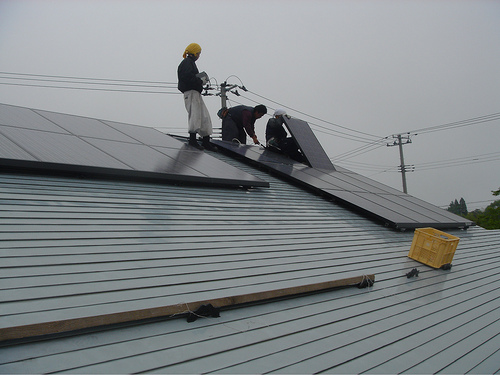<image>
Is the man on the hat? No. The man is not positioned on the hat. They may be near each other, but the man is not supported by or resting on top of the hat. 